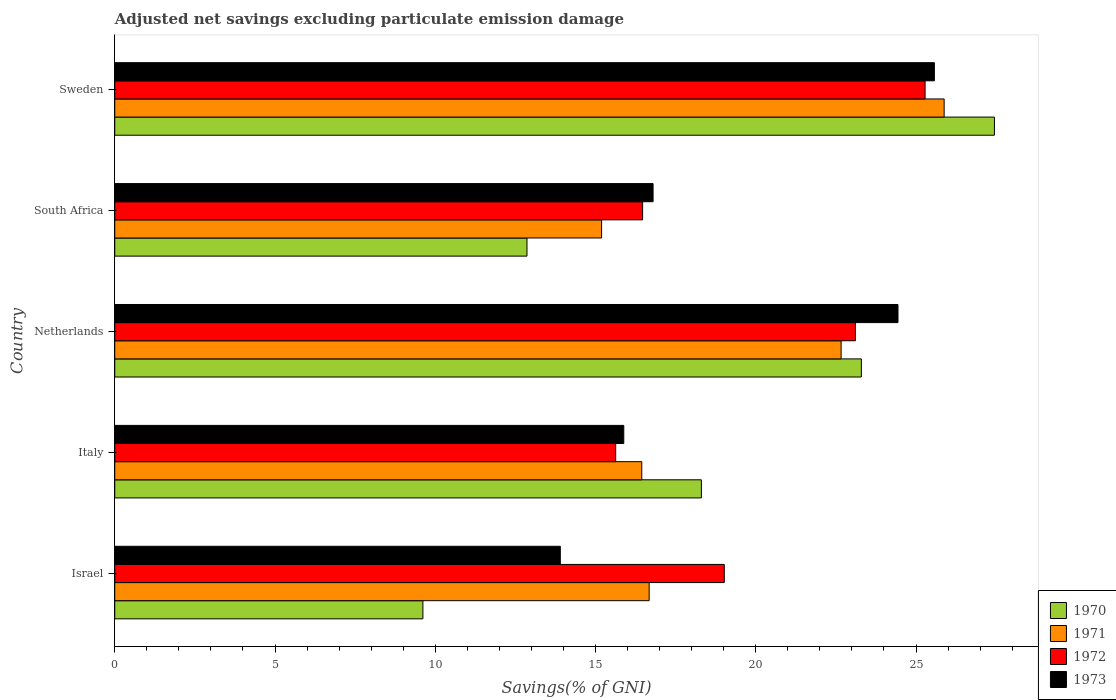Are the number of bars per tick equal to the number of legend labels?
Ensure brevity in your answer.  Yes. How many bars are there on the 3rd tick from the top?
Offer a very short reply. 4. How many bars are there on the 5th tick from the bottom?
Offer a very short reply. 4. In how many cases, is the number of bars for a given country not equal to the number of legend labels?
Make the answer very short. 0. What is the adjusted net savings in 1972 in Sweden?
Your answer should be compact. 25.28. Across all countries, what is the maximum adjusted net savings in 1972?
Your answer should be very brief. 25.28. Across all countries, what is the minimum adjusted net savings in 1972?
Make the answer very short. 15.63. In which country was the adjusted net savings in 1971 minimum?
Offer a very short reply. South Africa. What is the total adjusted net savings in 1970 in the graph?
Keep it short and to the point. 91.52. What is the difference between the adjusted net savings in 1970 in Israel and that in Sweden?
Offer a very short reply. -17.83. What is the difference between the adjusted net savings in 1970 in Sweden and the adjusted net savings in 1972 in Netherlands?
Provide a succinct answer. 4.34. What is the average adjusted net savings in 1971 per country?
Keep it short and to the point. 19.37. What is the difference between the adjusted net savings in 1971 and adjusted net savings in 1972 in Italy?
Offer a very short reply. 0.81. In how many countries, is the adjusted net savings in 1972 greater than 19 %?
Keep it short and to the point. 3. What is the ratio of the adjusted net savings in 1970 in Netherlands to that in South Africa?
Your answer should be compact. 1.81. What is the difference between the highest and the second highest adjusted net savings in 1971?
Your response must be concise. 3.21. What is the difference between the highest and the lowest adjusted net savings in 1970?
Provide a short and direct response. 17.83. In how many countries, is the adjusted net savings in 1973 greater than the average adjusted net savings in 1973 taken over all countries?
Make the answer very short. 2. Is the sum of the adjusted net savings in 1973 in Italy and Netherlands greater than the maximum adjusted net savings in 1970 across all countries?
Offer a terse response. Yes. Is it the case that in every country, the sum of the adjusted net savings in 1971 and adjusted net savings in 1972 is greater than the sum of adjusted net savings in 1973 and adjusted net savings in 1970?
Provide a short and direct response. No. What does the 4th bar from the top in Netherlands represents?
Ensure brevity in your answer.  1970. What does the 1st bar from the bottom in Italy represents?
Provide a short and direct response. 1970. Are all the bars in the graph horizontal?
Provide a succinct answer. Yes. What is the difference between two consecutive major ticks on the X-axis?
Provide a short and direct response. 5. Are the values on the major ticks of X-axis written in scientific E-notation?
Your answer should be compact. No. How are the legend labels stacked?
Keep it short and to the point. Vertical. What is the title of the graph?
Keep it short and to the point. Adjusted net savings excluding particulate emission damage. Does "1960" appear as one of the legend labels in the graph?
Offer a very short reply. No. What is the label or title of the X-axis?
Your answer should be compact. Savings(% of GNI). What is the label or title of the Y-axis?
Your answer should be very brief. Country. What is the Savings(% of GNI) in 1970 in Israel?
Provide a succinct answer. 9.61. What is the Savings(% of GNI) in 1971 in Israel?
Your response must be concise. 16.67. What is the Savings(% of GNI) of 1972 in Israel?
Your response must be concise. 19.02. What is the Savings(% of GNI) of 1973 in Israel?
Make the answer very short. 13.9. What is the Savings(% of GNI) in 1970 in Italy?
Keep it short and to the point. 18.3. What is the Savings(% of GNI) of 1971 in Italy?
Make the answer very short. 16.44. What is the Savings(% of GNI) in 1972 in Italy?
Ensure brevity in your answer.  15.63. What is the Savings(% of GNI) in 1973 in Italy?
Your response must be concise. 15.88. What is the Savings(% of GNI) in 1970 in Netherlands?
Your answer should be compact. 23.3. What is the Savings(% of GNI) of 1971 in Netherlands?
Offer a terse response. 22.66. What is the Savings(% of GNI) of 1972 in Netherlands?
Give a very brief answer. 23.11. What is the Savings(% of GNI) in 1973 in Netherlands?
Make the answer very short. 24.44. What is the Savings(% of GNI) of 1970 in South Africa?
Your answer should be compact. 12.86. What is the Savings(% of GNI) in 1971 in South Africa?
Keep it short and to the point. 15.19. What is the Savings(% of GNI) of 1972 in South Africa?
Your answer should be compact. 16.47. What is the Savings(% of GNI) of 1973 in South Africa?
Your response must be concise. 16.8. What is the Savings(% of GNI) in 1970 in Sweden?
Provide a succinct answer. 27.45. What is the Savings(% of GNI) in 1971 in Sweden?
Your answer should be compact. 25.88. What is the Savings(% of GNI) in 1972 in Sweden?
Make the answer very short. 25.28. What is the Savings(% of GNI) of 1973 in Sweden?
Your response must be concise. 25.57. Across all countries, what is the maximum Savings(% of GNI) of 1970?
Provide a succinct answer. 27.45. Across all countries, what is the maximum Savings(% of GNI) of 1971?
Provide a succinct answer. 25.88. Across all countries, what is the maximum Savings(% of GNI) of 1972?
Offer a very short reply. 25.28. Across all countries, what is the maximum Savings(% of GNI) in 1973?
Your answer should be very brief. 25.57. Across all countries, what is the minimum Savings(% of GNI) of 1970?
Ensure brevity in your answer.  9.61. Across all countries, what is the minimum Savings(% of GNI) in 1971?
Give a very brief answer. 15.19. Across all countries, what is the minimum Savings(% of GNI) in 1972?
Your answer should be very brief. 15.63. Across all countries, what is the minimum Savings(% of GNI) in 1973?
Your answer should be compact. 13.9. What is the total Savings(% of GNI) in 1970 in the graph?
Give a very brief answer. 91.52. What is the total Savings(% of GNI) of 1971 in the graph?
Provide a short and direct response. 96.85. What is the total Savings(% of GNI) in 1972 in the graph?
Give a very brief answer. 99.51. What is the total Savings(% of GNI) of 1973 in the graph?
Your answer should be compact. 96.59. What is the difference between the Savings(% of GNI) of 1970 in Israel and that in Italy?
Give a very brief answer. -8.69. What is the difference between the Savings(% of GNI) in 1971 in Israel and that in Italy?
Offer a terse response. 0.23. What is the difference between the Savings(% of GNI) of 1972 in Israel and that in Italy?
Ensure brevity in your answer.  3.39. What is the difference between the Savings(% of GNI) of 1973 in Israel and that in Italy?
Provide a short and direct response. -1.98. What is the difference between the Savings(% of GNI) in 1970 in Israel and that in Netherlands?
Provide a succinct answer. -13.68. What is the difference between the Savings(% of GNI) in 1971 in Israel and that in Netherlands?
Offer a terse response. -5.99. What is the difference between the Savings(% of GNI) in 1972 in Israel and that in Netherlands?
Offer a terse response. -4.09. What is the difference between the Savings(% of GNI) of 1973 in Israel and that in Netherlands?
Ensure brevity in your answer.  -10.54. What is the difference between the Savings(% of GNI) of 1970 in Israel and that in South Africa?
Ensure brevity in your answer.  -3.25. What is the difference between the Savings(% of GNI) in 1971 in Israel and that in South Africa?
Provide a short and direct response. 1.48. What is the difference between the Savings(% of GNI) of 1972 in Israel and that in South Africa?
Make the answer very short. 2.55. What is the difference between the Savings(% of GNI) in 1973 in Israel and that in South Africa?
Give a very brief answer. -2.89. What is the difference between the Savings(% of GNI) of 1970 in Israel and that in Sweden?
Ensure brevity in your answer.  -17.83. What is the difference between the Savings(% of GNI) in 1971 in Israel and that in Sweden?
Ensure brevity in your answer.  -9.2. What is the difference between the Savings(% of GNI) of 1972 in Israel and that in Sweden?
Offer a very short reply. -6.27. What is the difference between the Savings(% of GNI) in 1973 in Israel and that in Sweden?
Provide a succinct answer. -11.67. What is the difference between the Savings(% of GNI) in 1970 in Italy and that in Netherlands?
Offer a terse response. -4.99. What is the difference between the Savings(% of GNI) of 1971 in Italy and that in Netherlands?
Offer a terse response. -6.22. What is the difference between the Savings(% of GNI) in 1972 in Italy and that in Netherlands?
Provide a short and direct response. -7.48. What is the difference between the Savings(% of GNI) in 1973 in Italy and that in Netherlands?
Provide a short and direct response. -8.56. What is the difference between the Savings(% of GNI) in 1970 in Italy and that in South Africa?
Keep it short and to the point. 5.44. What is the difference between the Savings(% of GNI) of 1971 in Italy and that in South Africa?
Ensure brevity in your answer.  1.25. What is the difference between the Savings(% of GNI) of 1972 in Italy and that in South Africa?
Provide a succinct answer. -0.84. What is the difference between the Savings(% of GNI) of 1973 in Italy and that in South Africa?
Provide a short and direct response. -0.91. What is the difference between the Savings(% of GNI) in 1970 in Italy and that in Sweden?
Give a very brief answer. -9.14. What is the difference between the Savings(% of GNI) of 1971 in Italy and that in Sweden?
Ensure brevity in your answer.  -9.43. What is the difference between the Savings(% of GNI) in 1972 in Italy and that in Sweden?
Offer a very short reply. -9.65. What is the difference between the Savings(% of GNI) of 1973 in Italy and that in Sweden?
Provide a succinct answer. -9.69. What is the difference between the Savings(% of GNI) of 1970 in Netherlands and that in South Africa?
Provide a succinct answer. 10.43. What is the difference between the Savings(% of GNI) in 1971 in Netherlands and that in South Africa?
Ensure brevity in your answer.  7.47. What is the difference between the Savings(% of GNI) of 1972 in Netherlands and that in South Africa?
Offer a terse response. 6.64. What is the difference between the Savings(% of GNI) of 1973 in Netherlands and that in South Africa?
Make the answer very short. 7.64. What is the difference between the Savings(% of GNI) of 1970 in Netherlands and that in Sweden?
Provide a short and direct response. -4.15. What is the difference between the Savings(% of GNI) in 1971 in Netherlands and that in Sweden?
Offer a very short reply. -3.21. What is the difference between the Savings(% of GNI) in 1972 in Netherlands and that in Sweden?
Keep it short and to the point. -2.17. What is the difference between the Savings(% of GNI) in 1973 in Netherlands and that in Sweden?
Provide a succinct answer. -1.14. What is the difference between the Savings(% of GNI) in 1970 in South Africa and that in Sweden?
Provide a short and direct response. -14.59. What is the difference between the Savings(% of GNI) in 1971 in South Africa and that in Sweden?
Ensure brevity in your answer.  -10.69. What is the difference between the Savings(% of GNI) of 1972 in South Africa and that in Sweden?
Make the answer very short. -8.81. What is the difference between the Savings(% of GNI) in 1973 in South Africa and that in Sweden?
Provide a short and direct response. -8.78. What is the difference between the Savings(% of GNI) of 1970 in Israel and the Savings(% of GNI) of 1971 in Italy?
Provide a short and direct response. -6.83. What is the difference between the Savings(% of GNI) in 1970 in Israel and the Savings(% of GNI) in 1972 in Italy?
Offer a very short reply. -6.02. What is the difference between the Savings(% of GNI) of 1970 in Israel and the Savings(% of GNI) of 1973 in Italy?
Offer a terse response. -6.27. What is the difference between the Savings(% of GNI) of 1971 in Israel and the Savings(% of GNI) of 1972 in Italy?
Offer a very short reply. 1.04. What is the difference between the Savings(% of GNI) of 1971 in Israel and the Savings(% of GNI) of 1973 in Italy?
Your response must be concise. 0.79. What is the difference between the Savings(% of GNI) in 1972 in Israel and the Savings(% of GNI) in 1973 in Italy?
Provide a short and direct response. 3.14. What is the difference between the Savings(% of GNI) of 1970 in Israel and the Savings(% of GNI) of 1971 in Netherlands?
Offer a very short reply. -13.05. What is the difference between the Savings(% of GNI) in 1970 in Israel and the Savings(% of GNI) in 1972 in Netherlands?
Your answer should be very brief. -13.49. What is the difference between the Savings(% of GNI) in 1970 in Israel and the Savings(% of GNI) in 1973 in Netherlands?
Your answer should be very brief. -14.82. What is the difference between the Savings(% of GNI) in 1971 in Israel and the Savings(% of GNI) in 1972 in Netherlands?
Offer a very short reply. -6.44. What is the difference between the Savings(% of GNI) in 1971 in Israel and the Savings(% of GNI) in 1973 in Netherlands?
Offer a terse response. -7.76. What is the difference between the Savings(% of GNI) in 1972 in Israel and the Savings(% of GNI) in 1973 in Netherlands?
Give a very brief answer. -5.42. What is the difference between the Savings(% of GNI) in 1970 in Israel and the Savings(% of GNI) in 1971 in South Africa?
Keep it short and to the point. -5.58. What is the difference between the Savings(% of GNI) of 1970 in Israel and the Savings(% of GNI) of 1972 in South Africa?
Offer a very short reply. -6.86. What is the difference between the Savings(% of GNI) in 1970 in Israel and the Savings(% of GNI) in 1973 in South Africa?
Offer a terse response. -7.18. What is the difference between the Savings(% of GNI) of 1971 in Israel and the Savings(% of GNI) of 1972 in South Africa?
Provide a succinct answer. 0.2. What is the difference between the Savings(% of GNI) of 1971 in Israel and the Savings(% of GNI) of 1973 in South Africa?
Make the answer very short. -0.12. What is the difference between the Savings(% of GNI) of 1972 in Israel and the Savings(% of GNI) of 1973 in South Africa?
Keep it short and to the point. 2.22. What is the difference between the Savings(% of GNI) of 1970 in Israel and the Savings(% of GNI) of 1971 in Sweden?
Make the answer very short. -16.26. What is the difference between the Savings(% of GNI) of 1970 in Israel and the Savings(% of GNI) of 1972 in Sweden?
Keep it short and to the point. -15.67. What is the difference between the Savings(% of GNI) in 1970 in Israel and the Savings(% of GNI) in 1973 in Sweden?
Provide a short and direct response. -15.96. What is the difference between the Savings(% of GNI) of 1971 in Israel and the Savings(% of GNI) of 1972 in Sweden?
Give a very brief answer. -8.61. What is the difference between the Savings(% of GNI) of 1971 in Israel and the Savings(% of GNI) of 1973 in Sweden?
Offer a very short reply. -8.9. What is the difference between the Savings(% of GNI) of 1972 in Israel and the Savings(% of GNI) of 1973 in Sweden?
Your answer should be compact. -6.56. What is the difference between the Savings(% of GNI) in 1970 in Italy and the Savings(% of GNI) in 1971 in Netherlands?
Make the answer very short. -4.36. What is the difference between the Savings(% of GNI) in 1970 in Italy and the Savings(% of GNI) in 1972 in Netherlands?
Offer a terse response. -4.81. What is the difference between the Savings(% of GNI) of 1970 in Italy and the Savings(% of GNI) of 1973 in Netherlands?
Ensure brevity in your answer.  -6.13. What is the difference between the Savings(% of GNI) of 1971 in Italy and the Savings(% of GNI) of 1972 in Netherlands?
Provide a succinct answer. -6.67. What is the difference between the Savings(% of GNI) in 1971 in Italy and the Savings(% of GNI) in 1973 in Netherlands?
Offer a terse response. -7.99. What is the difference between the Savings(% of GNI) of 1972 in Italy and the Savings(% of GNI) of 1973 in Netherlands?
Ensure brevity in your answer.  -8.81. What is the difference between the Savings(% of GNI) of 1970 in Italy and the Savings(% of GNI) of 1971 in South Africa?
Keep it short and to the point. 3.11. What is the difference between the Savings(% of GNI) of 1970 in Italy and the Savings(% of GNI) of 1972 in South Africa?
Offer a very short reply. 1.83. What is the difference between the Savings(% of GNI) of 1970 in Italy and the Savings(% of GNI) of 1973 in South Africa?
Offer a very short reply. 1.51. What is the difference between the Savings(% of GNI) in 1971 in Italy and the Savings(% of GNI) in 1972 in South Africa?
Your answer should be very brief. -0.03. What is the difference between the Savings(% of GNI) in 1971 in Italy and the Savings(% of GNI) in 1973 in South Africa?
Provide a short and direct response. -0.35. What is the difference between the Savings(% of GNI) of 1972 in Italy and the Savings(% of GNI) of 1973 in South Africa?
Your answer should be very brief. -1.17. What is the difference between the Savings(% of GNI) of 1970 in Italy and the Savings(% of GNI) of 1971 in Sweden?
Your answer should be compact. -7.57. What is the difference between the Savings(% of GNI) in 1970 in Italy and the Savings(% of GNI) in 1972 in Sweden?
Keep it short and to the point. -6.98. What is the difference between the Savings(% of GNI) in 1970 in Italy and the Savings(% of GNI) in 1973 in Sweden?
Offer a terse response. -7.27. What is the difference between the Savings(% of GNI) of 1971 in Italy and the Savings(% of GNI) of 1972 in Sweden?
Make the answer very short. -8.84. What is the difference between the Savings(% of GNI) of 1971 in Italy and the Savings(% of GNI) of 1973 in Sweden?
Make the answer very short. -9.13. What is the difference between the Savings(% of GNI) in 1972 in Italy and the Savings(% of GNI) in 1973 in Sweden?
Keep it short and to the point. -9.94. What is the difference between the Savings(% of GNI) of 1970 in Netherlands and the Savings(% of GNI) of 1971 in South Africa?
Provide a short and direct response. 8.11. What is the difference between the Savings(% of GNI) of 1970 in Netherlands and the Savings(% of GNI) of 1972 in South Africa?
Give a very brief answer. 6.83. What is the difference between the Savings(% of GNI) of 1970 in Netherlands and the Savings(% of GNI) of 1973 in South Africa?
Your answer should be very brief. 6.5. What is the difference between the Savings(% of GNI) of 1971 in Netherlands and the Savings(% of GNI) of 1972 in South Africa?
Offer a very short reply. 6.19. What is the difference between the Savings(% of GNI) in 1971 in Netherlands and the Savings(% of GNI) in 1973 in South Africa?
Your response must be concise. 5.87. What is the difference between the Savings(% of GNI) of 1972 in Netherlands and the Savings(% of GNI) of 1973 in South Africa?
Your answer should be very brief. 6.31. What is the difference between the Savings(% of GNI) in 1970 in Netherlands and the Savings(% of GNI) in 1971 in Sweden?
Ensure brevity in your answer.  -2.58. What is the difference between the Savings(% of GNI) of 1970 in Netherlands and the Savings(% of GNI) of 1972 in Sweden?
Offer a terse response. -1.99. What is the difference between the Savings(% of GNI) in 1970 in Netherlands and the Savings(% of GNI) in 1973 in Sweden?
Your response must be concise. -2.28. What is the difference between the Savings(% of GNI) of 1971 in Netherlands and the Savings(% of GNI) of 1972 in Sweden?
Offer a terse response. -2.62. What is the difference between the Savings(% of GNI) of 1971 in Netherlands and the Savings(% of GNI) of 1973 in Sweden?
Provide a short and direct response. -2.91. What is the difference between the Savings(% of GNI) of 1972 in Netherlands and the Savings(% of GNI) of 1973 in Sweden?
Your response must be concise. -2.46. What is the difference between the Savings(% of GNI) in 1970 in South Africa and the Savings(% of GNI) in 1971 in Sweden?
Your answer should be very brief. -13.02. What is the difference between the Savings(% of GNI) in 1970 in South Africa and the Savings(% of GNI) in 1972 in Sweden?
Keep it short and to the point. -12.42. What is the difference between the Savings(% of GNI) of 1970 in South Africa and the Savings(% of GNI) of 1973 in Sweden?
Your answer should be very brief. -12.71. What is the difference between the Savings(% of GNI) in 1971 in South Africa and the Savings(% of GNI) in 1972 in Sweden?
Offer a very short reply. -10.09. What is the difference between the Savings(% of GNI) of 1971 in South Africa and the Savings(% of GNI) of 1973 in Sweden?
Provide a short and direct response. -10.38. What is the difference between the Savings(% of GNI) of 1972 in South Africa and the Savings(% of GNI) of 1973 in Sweden?
Offer a very short reply. -9.1. What is the average Savings(% of GNI) of 1970 per country?
Provide a short and direct response. 18.3. What is the average Savings(% of GNI) in 1971 per country?
Your answer should be very brief. 19.37. What is the average Savings(% of GNI) in 1972 per country?
Offer a very short reply. 19.9. What is the average Savings(% of GNI) in 1973 per country?
Provide a succinct answer. 19.32. What is the difference between the Savings(% of GNI) of 1970 and Savings(% of GNI) of 1971 in Israel?
Offer a terse response. -7.06. What is the difference between the Savings(% of GNI) of 1970 and Savings(% of GNI) of 1972 in Israel?
Offer a very short reply. -9.4. What is the difference between the Savings(% of GNI) in 1970 and Savings(% of GNI) in 1973 in Israel?
Offer a terse response. -4.29. What is the difference between the Savings(% of GNI) of 1971 and Savings(% of GNI) of 1972 in Israel?
Ensure brevity in your answer.  -2.34. What is the difference between the Savings(% of GNI) of 1971 and Savings(% of GNI) of 1973 in Israel?
Provide a succinct answer. 2.77. What is the difference between the Savings(% of GNI) in 1972 and Savings(% of GNI) in 1973 in Israel?
Give a very brief answer. 5.12. What is the difference between the Savings(% of GNI) of 1970 and Savings(% of GNI) of 1971 in Italy?
Make the answer very short. 1.86. What is the difference between the Savings(% of GNI) of 1970 and Savings(% of GNI) of 1972 in Italy?
Your answer should be compact. 2.67. What is the difference between the Savings(% of GNI) of 1970 and Savings(% of GNI) of 1973 in Italy?
Give a very brief answer. 2.42. What is the difference between the Savings(% of GNI) in 1971 and Savings(% of GNI) in 1972 in Italy?
Provide a succinct answer. 0.81. What is the difference between the Savings(% of GNI) in 1971 and Savings(% of GNI) in 1973 in Italy?
Keep it short and to the point. 0.56. What is the difference between the Savings(% of GNI) of 1972 and Savings(% of GNI) of 1973 in Italy?
Provide a succinct answer. -0.25. What is the difference between the Savings(% of GNI) in 1970 and Savings(% of GNI) in 1971 in Netherlands?
Provide a succinct answer. 0.63. What is the difference between the Savings(% of GNI) of 1970 and Savings(% of GNI) of 1972 in Netherlands?
Your answer should be compact. 0.19. What is the difference between the Savings(% of GNI) of 1970 and Savings(% of GNI) of 1973 in Netherlands?
Give a very brief answer. -1.14. What is the difference between the Savings(% of GNI) in 1971 and Savings(% of GNI) in 1972 in Netherlands?
Offer a very short reply. -0.45. What is the difference between the Savings(% of GNI) in 1971 and Savings(% of GNI) in 1973 in Netherlands?
Keep it short and to the point. -1.77. What is the difference between the Savings(% of GNI) of 1972 and Savings(% of GNI) of 1973 in Netherlands?
Provide a short and direct response. -1.33. What is the difference between the Savings(% of GNI) of 1970 and Savings(% of GNI) of 1971 in South Africa?
Your answer should be very brief. -2.33. What is the difference between the Savings(% of GNI) in 1970 and Savings(% of GNI) in 1972 in South Africa?
Keep it short and to the point. -3.61. What is the difference between the Savings(% of GNI) of 1970 and Savings(% of GNI) of 1973 in South Africa?
Offer a very short reply. -3.93. What is the difference between the Savings(% of GNI) of 1971 and Savings(% of GNI) of 1972 in South Africa?
Provide a short and direct response. -1.28. What is the difference between the Savings(% of GNI) in 1971 and Savings(% of GNI) in 1973 in South Africa?
Your answer should be very brief. -1.61. What is the difference between the Savings(% of GNI) of 1972 and Savings(% of GNI) of 1973 in South Africa?
Provide a succinct answer. -0.33. What is the difference between the Savings(% of GNI) of 1970 and Savings(% of GNI) of 1971 in Sweden?
Your response must be concise. 1.57. What is the difference between the Savings(% of GNI) of 1970 and Savings(% of GNI) of 1972 in Sweden?
Your response must be concise. 2.16. What is the difference between the Savings(% of GNI) of 1970 and Savings(% of GNI) of 1973 in Sweden?
Ensure brevity in your answer.  1.87. What is the difference between the Savings(% of GNI) of 1971 and Savings(% of GNI) of 1972 in Sweden?
Provide a short and direct response. 0.59. What is the difference between the Savings(% of GNI) of 1971 and Savings(% of GNI) of 1973 in Sweden?
Your answer should be compact. 0.3. What is the difference between the Savings(% of GNI) in 1972 and Savings(% of GNI) in 1973 in Sweden?
Your response must be concise. -0.29. What is the ratio of the Savings(% of GNI) in 1970 in Israel to that in Italy?
Your answer should be very brief. 0.53. What is the ratio of the Savings(% of GNI) in 1972 in Israel to that in Italy?
Your answer should be very brief. 1.22. What is the ratio of the Savings(% of GNI) in 1973 in Israel to that in Italy?
Make the answer very short. 0.88. What is the ratio of the Savings(% of GNI) in 1970 in Israel to that in Netherlands?
Your response must be concise. 0.41. What is the ratio of the Savings(% of GNI) of 1971 in Israel to that in Netherlands?
Your response must be concise. 0.74. What is the ratio of the Savings(% of GNI) in 1972 in Israel to that in Netherlands?
Give a very brief answer. 0.82. What is the ratio of the Savings(% of GNI) in 1973 in Israel to that in Netherlands?
Ensure brevity in your answer.  0.57. What is the ratio of the Savings(% of GNI) in 1970 in Israel to that in South Africa?
Your response must be concise. 0.75. What is the ratio of the Savings(% of GNI) in 1971 in Israel to that in South Africa?
Keep it short and to the point. 1.1. What is the ratio of the Savings(% of GNI) of 1972 in Israel to that in South Africa?
Keep it short and to the point. 1.15. What is the ratio of the Savings(% of GNI) of 1973 in Israel to that in South Africa?
Provide a short and direct response. 0.83. What is the ratio of the Savings(% of GNI) of 1970 in Israel to that in Sweden?
Provide a succinct answer. 0.35. What is the ratio of the Savings(% of GNI) in 1971 in Israel to that in Sweden?
Keep it short and to the point. 0.64. What is the ratio of the Savings(% of GNI) of 1972 in Israel to that in Sweden?
Give a very brief answer. 0.75. What is the ratio of the Savings(% of GNI) in 1973 in Israel to that in Sweden?
Offer a terse response. 0.54. What is the ratio of the Savings(% of GNI) in 1970 in Italy to that in Netherlands?
Ensure brevity in your answer.  0.79. What is the ratio of the Savings(% of GNI) of 1971 in Italy to that in Netherlands?
Offer a terse response. 0.73. What is the ratio of the Savings(% of GNI) of 1972 in Italy to that in Netherlands?
Keep it short and to the point. 0.68. What is the ratio of the Savings(% of GNI) in 1973 in Italy to that in Netherlands?
Your answer should be very brief. 0.65. What is the ratio of the Savings(% of GNI) of 1970 in Italy to that in South Africa?
Offer a terse response. 1.42. What is the ratio of the Savings(% of GNI) in 1971 in Italy to that in South Africa?
Make the answer very short. 1.08. What is the ratio of the Savings(% of GNI) in 1972 in Italy to that in South Africa?
Make the answer very short. 0.95. What is the ratio of the Savings(% of GNI) in 1973 in Italy to that in South Africa?
Give a very brief answer. 0.95. What is the ratio of the Savings(% of GNI) of 1970 in Italy to that in Sweden?
Your answer should be very brief. 0.67. What is the ratio of the Savings(% of GNI) of 1971 in Italy to that in Sweden?
Ensure brevity in your answer.  0.64. What is the ratio of the Savings(% of GNI) in 1972 in Italy to that in Sweden?
Ensure brevity in your answer.  0.62. What is the ratio of the Savings(% of GNI) in 1973 in Italy to that in Sweden?
Make the answer very short. 0.62. What is the ratio of the Savings(% of GNI) of 1970 in Netherlands to that in South Africa?
Provide a short and direct response. 1.81. What is the ratio of the Savings(% of GNI) in 1971 in Netherlands to that in South Africa?
Offer a very short reply. 1.49. What is the ratio of the Savings(% of GNI) of 1972 in Netherlands to that in South Africa?
Your response must be concise. 1.4. What is the ratio of the Savings(% of GNI) of 1973 in Netherlands to that in South Africa?
Your answer should be compact. 1.46. What is the ratio of the Savings(% of GNI) in 1970 in Netherlands to that in Sweden?
Provide a succinct answer. 0.85. What is the ratio of the Savings(% of GNI) of 1971 in Netherlands to that in Sweden?
Give a very brief answer. 0.88. What is the ratio of the Savings(% of GNI) in 1972 in Netherlands to that in Sweden?
Your answer should be very brief. 0.91. What is the ratio of the Savings(% of GNI) of 1973 in Netherlands to that in Sweden?
Offer a very short reply. 0.96. What is the ratio of the Savings(% of GNI) of 1970 in South Africa to that in Sweden?
Offer a terse response. 0.47. What is the ratio of the Savings(% of GNI) in 1971 in South Africa to that in Sweden?
Give a very brief answer. 0.59. What is the ratio of the Savings(% of GNI) in 1972 in South Africa to that in Sweden?
Your answer should be compact. 0.65. What is the ratio of the Savings(% of GNI) in 1973 in South Africa to that in Sweden?
Your answer should be very brief. 0.66. What is the difference between the highest and the second highest Savings(% of GNI) in 1970?
Give a very brief answer. 4.15. What is the difference between the highest and the second highest Savings(% of GNI) of 1971?
Give a very brief answer. 3.21. What is the difference between the highest and the second highest Savings(% of GNI) of 1972?
Make the answer very short. 2.17. What is the difference between the highest and the second highest Savings(% of GNI) in 1973?
Offer a very short reply. 1.14. What is the difference between the highest and the lowest Savings(% of GNI) of 1970?
Your answer should be compact. 17.83. What is the difference between the highest and the lowest Savings(% of GNI) in 1971?
Offer a terse response. 10.69. What is the difference between the highest and the lowest Savings(% of GNI) in 1972?
Your answer should be compact. 9.65. What is the difference between the highest and the lowest Savings(% of GNI) of 1973?
Provide a short and direct response. 11.67. 